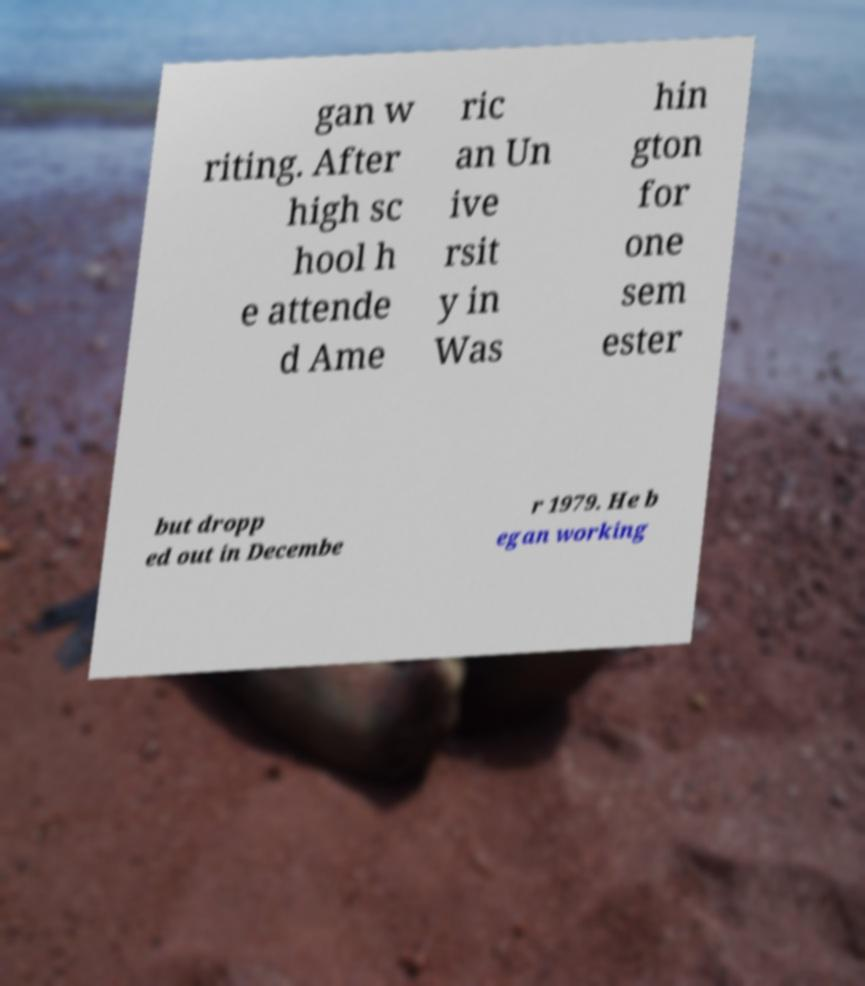Please read and relay the text visible in this image. What does it say? gan w riting. After high sc hool h e attende d Ame ric an Un ive rsit y in Was hin gton for one sem ester but dropp ed out in Decembe r 1979. He b egan working 